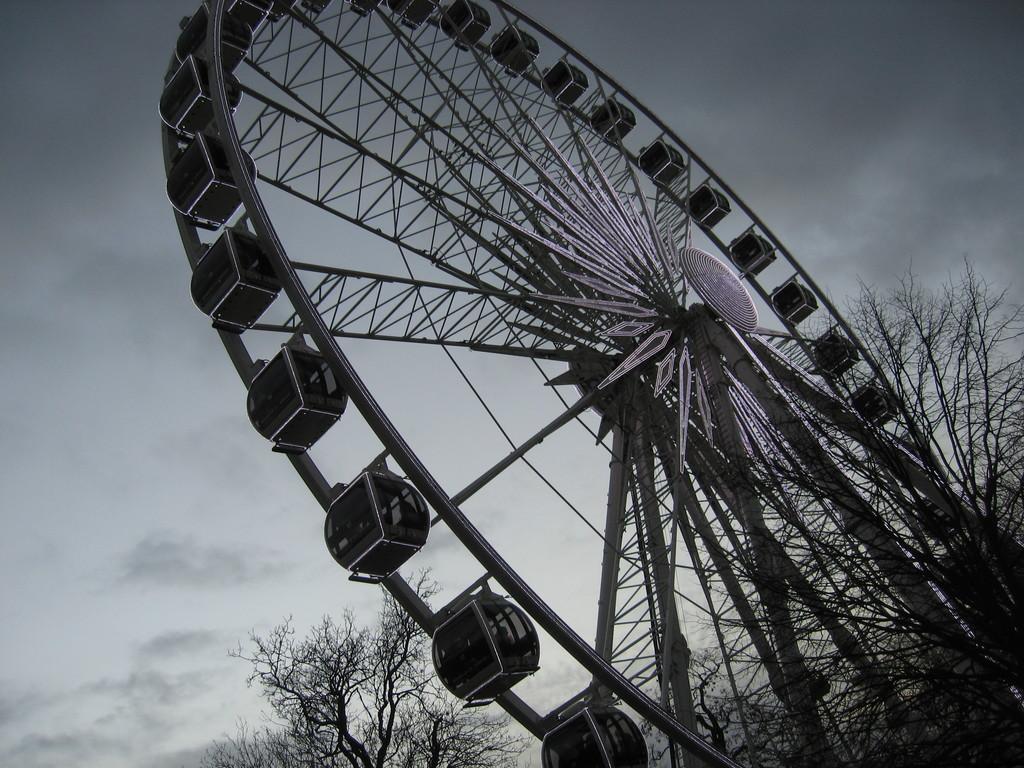Could you give a brief overview of what you see in this image? In this image I can see a giant wheel. Background I can see dried trees and sky in gray color. 